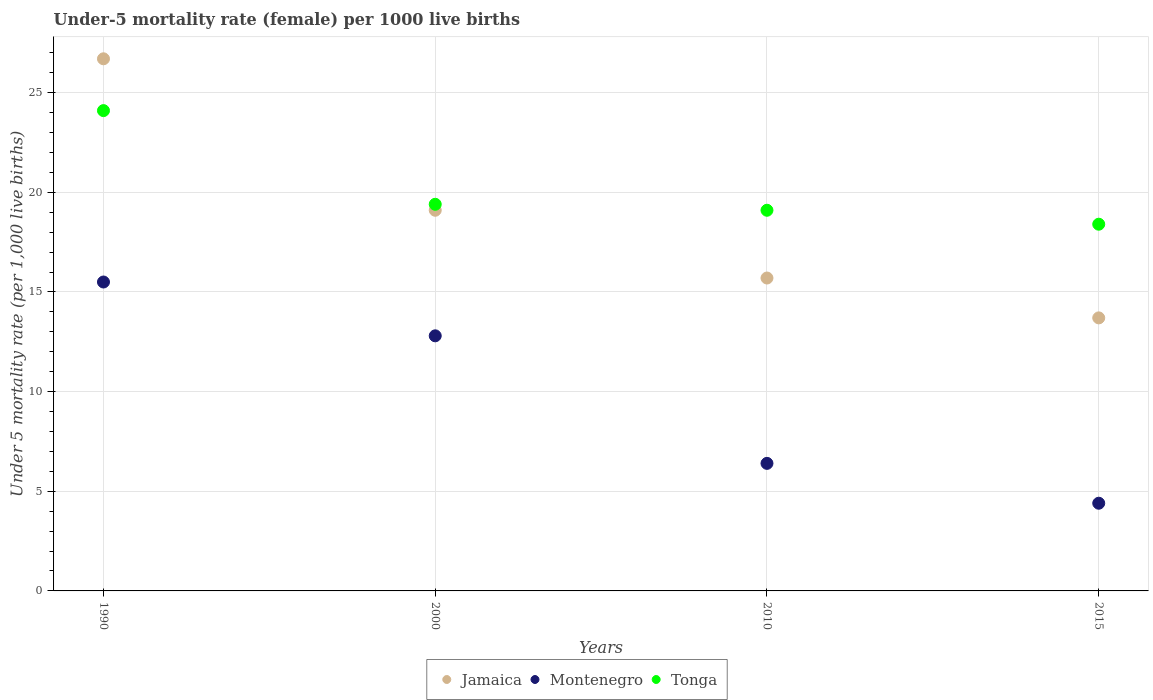What is the under-five mortality rate in Tonga in 1990?
Ensure brevity in your answer.  24.1. Across all years, what is the maximum under-five mortality rate in Montenegro?
Offer a very short reply. 15.5. In which year was the under-five mortality rate in Montenegro maximum?
Provide a succinct answer. 1990. In which year was the under-five mortality rate in Montenegro minimum?
Your response must be concise. 2015. What is the difference between the under-five mortality rate in Tonga in 2000 and the under-five mortality rate in Montenegro in 1990?
Your answer should be very brief. 3.9. What is the average under-five mortality rate in Montenegro per year?
Offer a very short reply. 9.78. In the year 2010, what is the difference between the under-five mortality rate in Tonga and under-five mortality rate in Montenegro?
Your response must be concise. 12.7. What is the ratio of the under-five mortality rate in Tonga in 1990 to that in 2015?
Make the answer very short. 1.31. Is the difference between the under-five mortality rate in Tonga in 2000 and 2010 greater than the difference between the under-five mortality rate in Montenegro in 2000 and 2010?
Offer a very short reply. No. What is the difference between the highest and the second highest under-five mortality rate in Tonga?
Offer a terse response. 4.7. In how many years, is the under-five mortality rate in Jamaica greater than the average under-five mortality rate in Jamaica taken over all years?
Provide a short and direct response. 2. Is the sum of the under-five mortality rate in Montenegro in 1990 and 2000 greater than the maximum under-five mortality rate in Tonga across all years?
Your answer should be compact. Yes. Is the under-five mortality rate in Montenegro strictly greater than the under-five mortality rate in Jamaica over the years?
Offer a very short reply. No. Is the under-five mortality rate in Tonga strictly less than the under-five mortality rate in Jamaica over the years?
Your response must be concise. No. How many dotlines are there?
Make the answer very short. 3. How many years are there in the graph?
Keep it short and to the point. 4. What is the difference between two consecutive major ticks on the Y-axis?
Keep it short and to the point. 5. Does the graph contain any zero values?
Provide a succinct answer. No. What is the title of the graph?
Make the answer very short. Under-5 mortality rate (female) per 1000 live births. What is the label or title of the X-axis?
Give a very brief answer. Years. What is the label or title of the Y-axis?
Provide a short and direct response. Under 5 mortality rate (per 1,0 live births). What is the Under 5 mortality rate (per 1,000 live births) of Jamaica in 1990?
Offer a very short reply. 26.7. What is the Under 5 mortality rate (per 1,000 live births) of Tonga in 1990?
Offer a terse response. 24.1. What is the Under 5 mortality rate (per 1,000 live births) of Jamaica in 2000?
Your response must be concise. 19.1. What is the Under 5 mortality rate (per 1,000 live births) in Tonga in 2000?
Keep it short and to the point. 19.4. What is the Under 5 mortality rate (per 1,000 live births) of Montenegro in 2010?
Make the answer very short. 6.4. What is the Under 5 mortality rate (per 1,000 live births) of Montenegro in 2015?
Make the answer very short. 4.4. What is the Under 5 mortality rate (per 1,000 live births) of Tonga in 2015?
Offer a terse response. 18.4. Across all years, what is the maximum Under 5 mortality rate (per 1,000 live births) in Jamaica?
Offer a terse response. 26.7. Across all years, what is the maximum Under 5 mortality rate (per 1,000 live births) in Montenegro?
Your response must be concise. 15.5. Across all years, what is the maximum Under 5 mortality rate (per 1,000 live births) in Tonga?
Give a very brief answer. 24.1. Across all years, what is the minimum Under 5 mortality rate (per 1,000 live births) in Jamaica?
Give a very brief answer. 13.7. Across all years, what is the minimum Under 5 mortality rate (per 1,000 live births) of Tonga?
Your answer should be compact. 18.4. What is the total Under 5 mortality rate (per 1,000 live births) in Jamaica in the graph?
Offer a terse response. 75.2. What is the total Under 5 mortality rate (per 1,000 live births) in Montenegro in the graph?
Provide a succinct answer. 39.1. What is the total Under 5 mortality rate (per 1,000 live births) of Tonga in the graph?
Keep it short and to the point. 81. What is the difference between the Under 5 mortality rate (per 1,000 live births) in Jamaica in 1990 and that in 2000?
Give a very brief answer. 7.6. What is the difference between the Under 5 mortality rate (per 1,000 live births) in Montenegro in 1990 and that in 2000?
Provide a succinct answer. 2.7. What is the difference between the Under 5 mortality rate (per 1,000 live births) of Jamaica in 1990 and that in 2010?
Provide a short and direct response. 11. What is the difference between the Under 5 mortality rate (per 1,000 live births) of Montenegro in 1990 and that in 2015?
Provide a short and direct response. 11.1. What is the difference between the Under 5 mortality rate (per 1,000 live births) of Tonga in 2000 and that in 2015?
Offer a very short reply. 1. What is the difference between the Under 5 mortality rate (per 1,000 live births) in Jamaica in 2010 and that in 2015?
Give a very brief answer. 2. What is the difference between the Under 5 mortality rate (per 1,000 live births) in Jamaica in 1990 and the Under 5 mortality rate (per 1,000 live births) in Montenegro in 2000?
Give a very brief answer. 13.9. What is the difference between the Under 5 mortality rate (per 1,000 live births) of Jamaica in 1990 and the Under 5 mortality rate (per 1,000 live births) of Tonga in 2000?
Offer a very short reply. 7.3. What is the difference between the Under 5 mortality rate (per 1,000 live births) of Jamaica in 1990 and the Under 5 mortality rate (per 1,000 live births) of Montenegro in 2010?
Provide a succinct answer. 20.3. What is the difference between the Under 5 mortality rate (per 1,000 live births) of Montenegro in 1990 and the Under 5 mortality rate (per 1,000 live births) of Tonga in 2010?
Ensure brevity in your answer.  -3.6. What is the difference between the Under 5 mortality rate (per 1,000 live births) of Jamaica in 1990 and the Under 5 mortality rate (per 1,000 live births) of Montenegro in 2015?
Offer a very short reply. 22.3. What is the difference between the Under 5 mortality rate (per 1,000 live births) of Jamaica in 2000 and the Under 5 mortality rate (per 1,000 live births) of Montenegro in 2010?
Your answer should be very brief. 12.7. What is the difference between the Under 5 mortality rate (per 1,000 live births) of Jamaica in 2000 and the Under 5 mortality rate (per 1,000 live births) of Montenegro in 2015?
Your answer should be compact. 14.7. What is the difference between the Under 5 mortality rate (per 1,000 live births) in Montenegro in 2000 and the Under 5 mortality rate (per 1,000 live births) in Tonga in 2015?
Provide a short and direct response. -5.6. What is the difference between the Under 5 mortality rate (per 1,000 live births) in Jamaica in 2010 and the Under 5 mortality rate (per 1,000 live births) in Montenegro in 2015?
Your answer should be compact. 11.3. What is the difference between the Under 5 mortality rate (per 1,000 live births) of Montenegro in 2010 and the Under 5 mortality rate (per 1,000 live births) of Tonga in 2015?
Your response must be concise. -12. What is the average Under 5 mortality rate (per 1,000 live births) of Jamaica per year?
Make the answer very short. 18.8. What is the average Under 5 mortality rate (per 1,000 live births) of Montenegro per year?
Offer a very short reply. 9.78. What is the average Under 5 mortality rate (per 1,000 live births) of Tonga per year?
Offer a very short reply. 20.25. In the year 1990, what is the difference between the Under 5 mortality rate (per 1,000 live births) of Jamaica and Under 5 mortality rate (per 1,000 live births) of Tonga?
Offer a very short reply. 2.6. In the year 1990, what is the difference between the Under 5 mortality rate (per 1,000 live births) of Montenegro and Under 5 mortality rate (per 1,000 live births) of Tonga?
Your answer should be very brief. -8.6. In the year 2000, what is the difference between the Under 5 mortality rate (per 1,000 live births) in Jamaica and Under 5 mortality rate (per 1,000 live births) in Montenegro?
Your response must be concise. 6.3. In the year 2000, what is the difference between the Under 5 mortality rate (per 1,000 live births) of Jamaica and Under 5 mortality rate (per 1,000 live births) of Tonga?
Keep it short and to the point. -0.3. In the year 2000, what is the difference between the Under 5 mortality rate (per 1,000 live births) of Montenegro and Under 5 mortality rate (per 1,000 live births) of Tonga?
Your response must be concise. -6.6. In the year 2010, what is the difference between the Under 5 mortality rate (per 1,000 live births) in Jamaica and Under 5 mortality rate (per 1,000 live births) in Tonga?
Your response must be concise. -3.4. In the year 2015, what is the difference between the Under 5 mortality rate (per 1,000 live births) in Jamaica and Under 5 mortality rate (per 1,000 live births) in Montenegro?
Keep it short and to the point. 9.3. In the year 2015, what is the difference between the Under 5 mortality rate (per 1,000 live births) of Jamaica and Under 5 mortality rate (per 1,000 live births) of Tonga?
Your response must be concise. -4.7. In the year 2015, what is the difference between the Under 5 mortality rate (per 1,000 live births) of Montenegro and Under 5 mortality rate (per 1,000 live births) of Tonga?
Your answer should be very brief. -14. What is the ratio of the Under 5 mortality rate (per 1,000 live births) of Jamaica in 1990 to that in 2000?
Offer a very short reply. 1.4. What is the ratio of the Under 5 mortality rate (per 1,000 live births) in Montenegro in 1990 to that in 2000?
Provide a short and direct response. 1.21. What is the ratio of the Under 5 mortality rate (per 1,000 live births) of Tonga in 1990 to that in 2000?
Make the answer very short. 1.24. What is the ratio of the Under 5 mortality rate (per 1,000 live births) of Jamaica in 1990 to that in 2010?
Offer a terse response. 1.7. What is the ratio of the Under 5 mortality rate (per 1,000 live births) of Montenegro in 1990 to that in 2010?
Ensure brevity in your answer.  2.42. What is the ratio of the Under 5 mortality rate (per 1,000 live births) of Tonga in 1990 to that in 2010?
Give a very brief answer. 1.26. What is the ratio of the Under 5 mortality rate (per 1,000 live births) in Jamaica in 1990 to that in 2015?
Your answer should be compact. 1.95. What is the ratio of the Under 5 mortality rate (per 1,000 live births) in Montenegro in 1990 to that in 2015?
Make the answer very short. 3.52. What is the ratio of the Under 5 mortality rate (per 1,000 live births) in Tonga in 1990 to that in 2015?
Make the answer very short. 1.31. What is the ratio of the Under 5 mortality rate (per 1,000 live births) in Jamaica in 2000 to that in 2010?
Provide a short and direct response. 1.22. What is the ratio of the Under 5 mortality rate (per 1,000 live births) of Tonga in 2000 to that in 2010?
Offer a terse response. 1.02. What is the ratio of the Under 5 mortality rate (per 1,000 live births) of Jamaica in 2000 to that in 2015?
Provide a short and direct response. 1.39. What is the ratio of the Under 5 mortality rate (per 1,000 live births) in Montenegro in 2000 to that in 2015?
Your answer should be very brief. 2.91. What is the ratio of the Under 5 mortality rate (per 1,000 live births) in Tonga in 2000 to that in 2015?
Your response must be concise. 1.05. What is the ratio of the Under 5 mortality rate (per 1,000 live births) of Jamaica in 2010 to that in 2015?
Your answer should be compact. 1.15. What is the ratio of the Under 5 mortality rate (per 1,000 live births) in Montenegro in 2010 to that in 2015?
Your answer should be very brief. 1.45. What is the ratio of the Under 5 mortality rate (per 1,000 live births) of Tonga in 2010 to that in 2015?
Offer a terse response. 1.04. What is the difference between the highest and the second highest Under 5 mortality rate (per 1,000 live births) in Jamaica?
Your answer should be compact. 7.6. What is the difference between the highest and the second highest Under 5 mortality rate (per 1,000 live births) in Tonga?
Give a very brief answer. 4.7. What is the difference between the highest and the lowest Under 5 mortality rate (per 1,000 live births) in Jamaica?
Offer a very short reply. 13. 